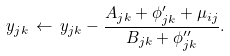<formula> <loc_0><loc_0><loc_500><loc_500>y _ { j k } \, \leftarrow \, y _ { j k } - \frac { A _ { j k } + \phi ^ { \prime } _ { j k } + \mu _ { i j } } { B _ { j k } + \phi ^ { \prime \prime } _ { j k } } .</formula> 